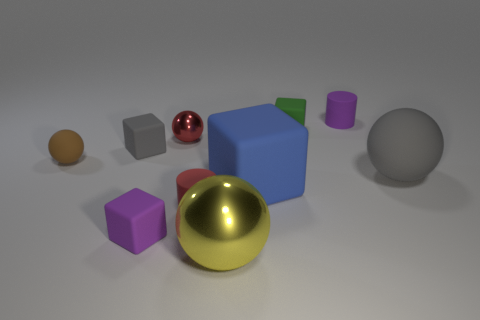Which objects in the image have reflective surfaces? The gold and silver spheres have highly reflective surfaces, mirroring the environment around them. How would you describe the light and shadows in the image? The image is softly lit from above, casting subtle shadows on the ground to the sides of the objects, which adds a sense of depth and dimension to the scene. 